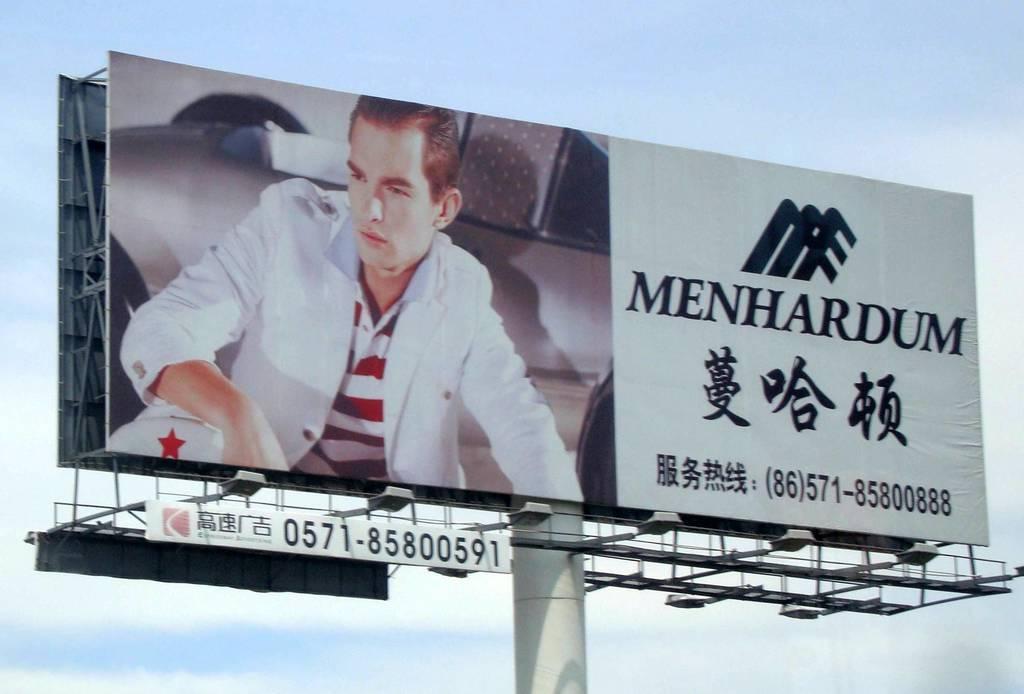Please provide a concise description of this image. In this picture I can observe an advertising flex in the middle of the picture. In the background there is sky. 